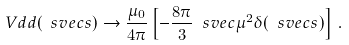Convert formula to latex. <formula><loc_0><loc_0><loc_500><loc_500>\ V d d ( \ s v e c { s } ) \to \frac { \mu _ { 0 } } { 4 \pi } \left [ - \frac { 8 \pi } { 3 } \ s v e c { \mu } ^ { 2 } \delta ( \ s v e c { s } ) \right ] \, .</formula> 